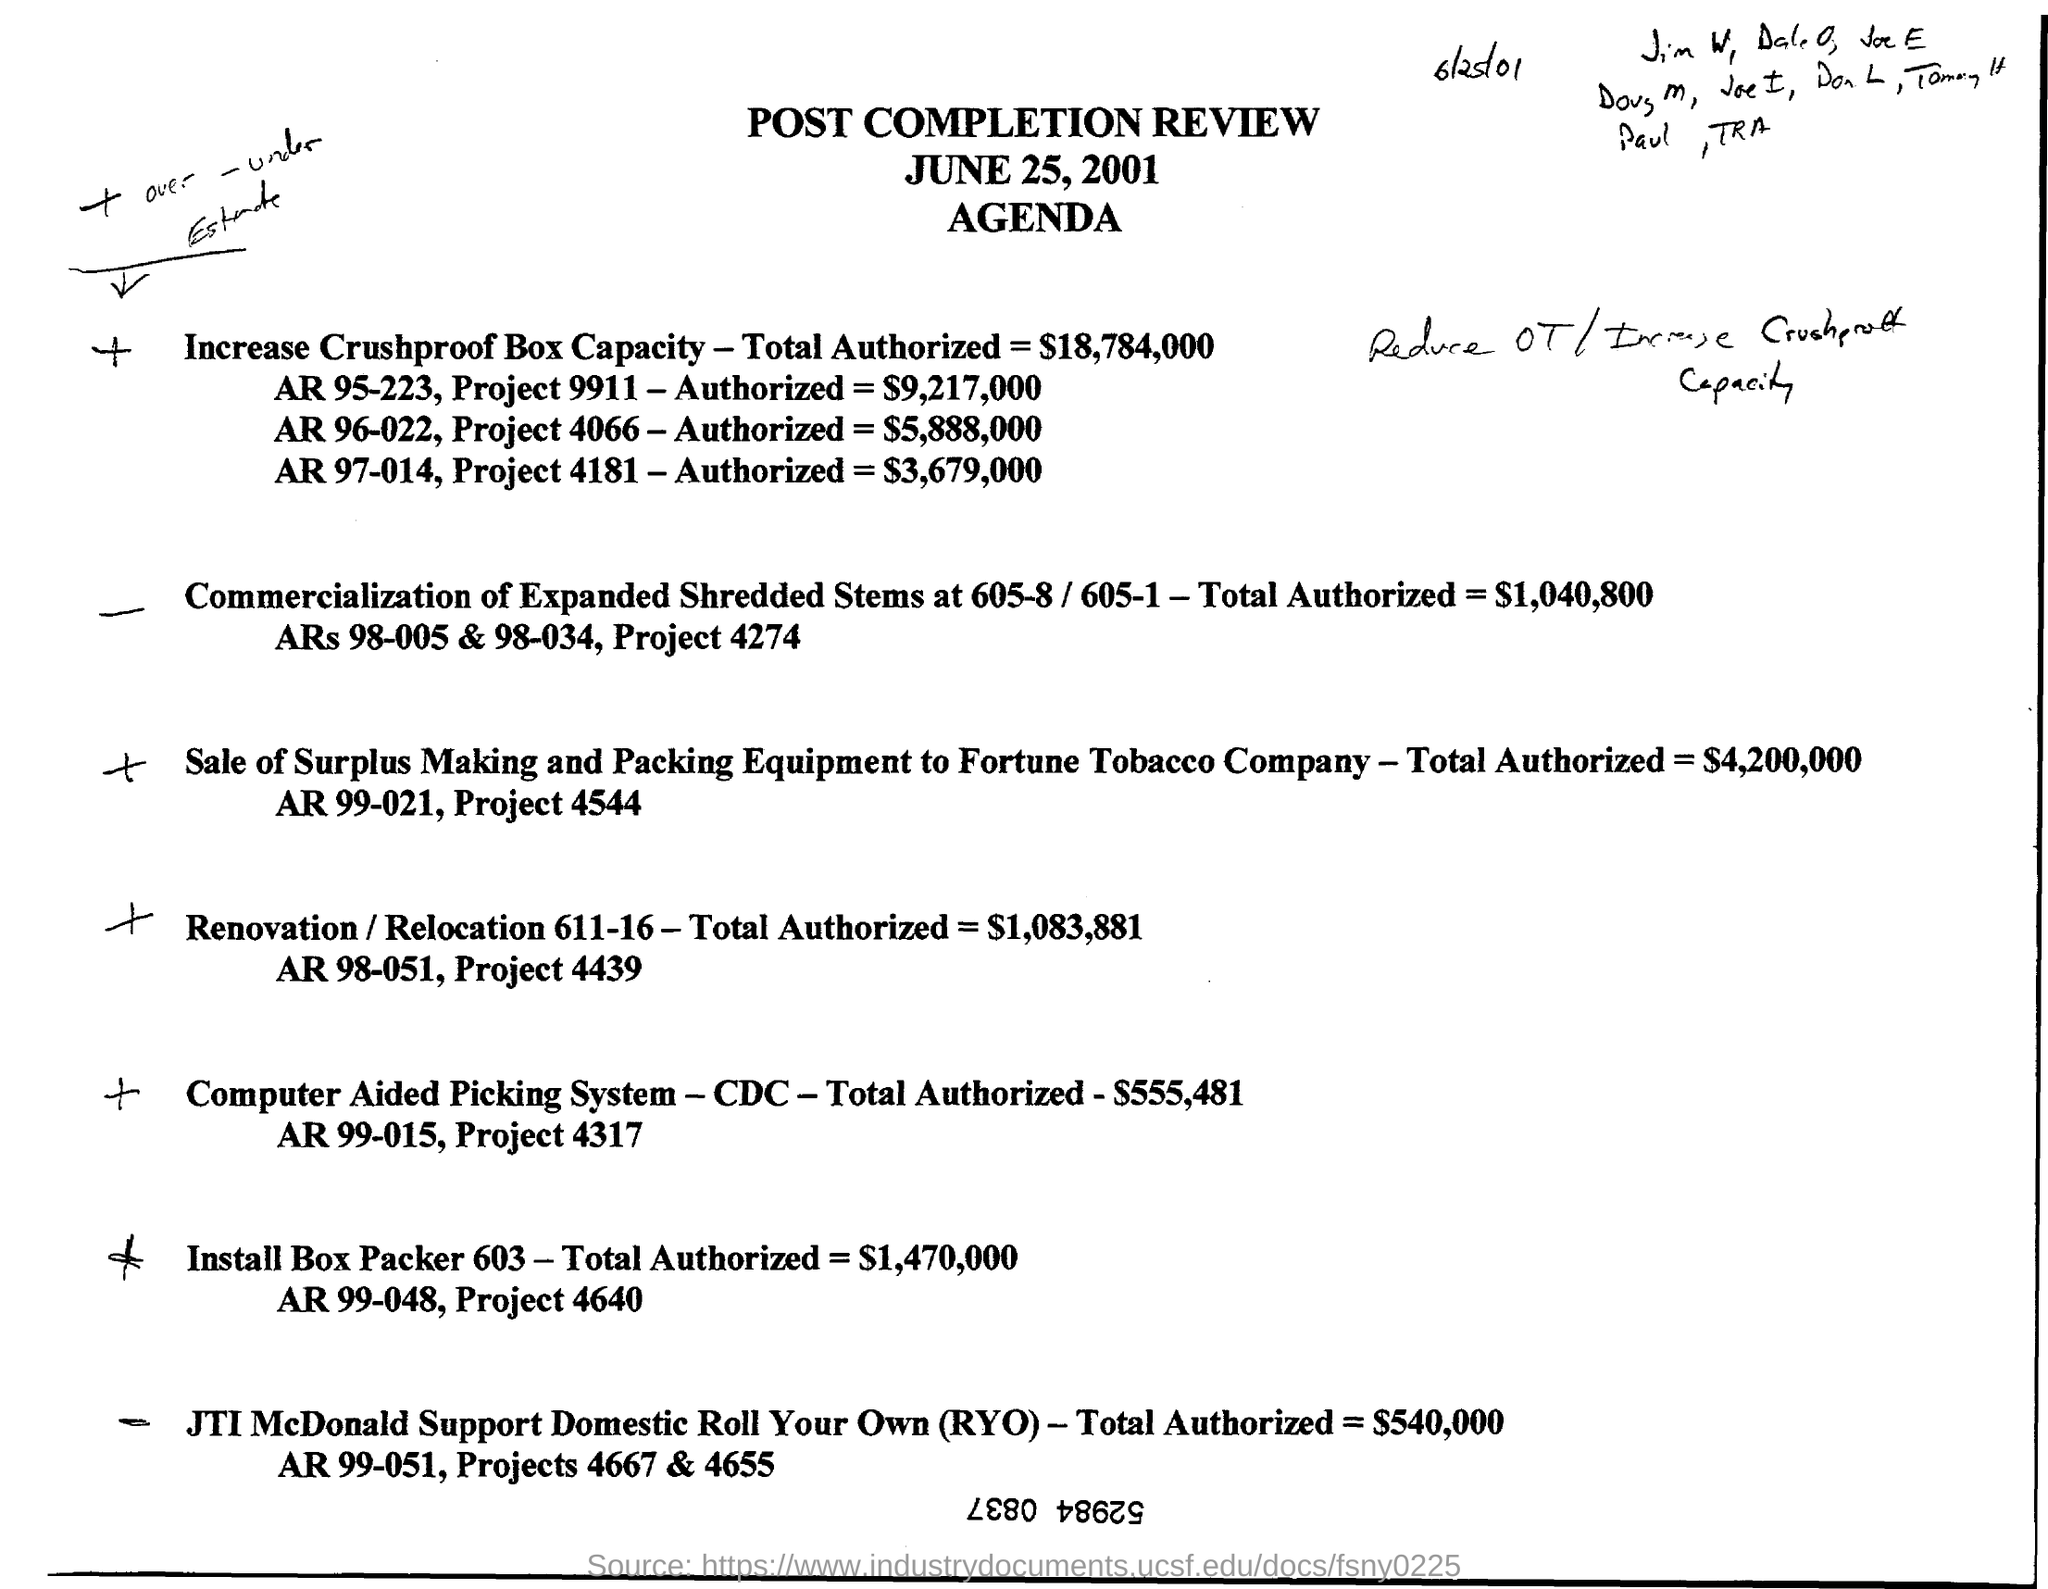What is the review about?
Provide a short and direct response. Post completion review. When is the document dated?
Offer a terse response. June 25, 2001. What is the total authorized amount for Computer Aided Picking System?
Provide a short and direct response. $555,481. What is Project 4439 about?
Provide a succinct answer. Renovation / relocation 611-16. 